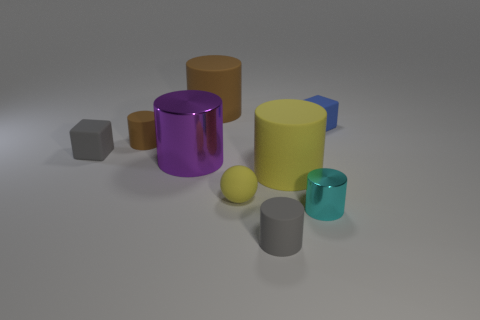What is the tiny brown cylinder made of?
Make the answer very short. Rubber. The big shiny thing has what color?
Keep it short and to the point. Purple. What is the color of the rubber cylinder that is both to the right of the large purple metal cylinder and left of the small yellow sphere?
Ensure brevity in your answer.  Brown. Do the blue cube and the large purple cylinder on the left side of the tiny blue matte thing have the same material?
Provide a short and direct response. No. How big is the metallic thing behind the shiny thing in front of the big yellow cylinder?
Your answer should be very brief. Large. Are there any other things that are the same color as the large metallic thing?
Provide a short and direct response. No. Do the block to the left of the blue matte block and the small cylinder left of the purple cylinder have the same material?
Make the answer very short. Yes. What is the thing that is both right of the small yellow matte object and behind the large metal object made of?
Your response must be concise. Rubber. There is a large yellow object; does it have the same shape as the large matte thing behind the big purple metallic cylinder?
Ensure brevity in your answer.  Yes. The tiny cylinder on the right side of the tiny rubber cylinder in front of the shiny object that is right of the large purple shiny cylinder is made of what material?
Your answer should be very brief. Metal. 